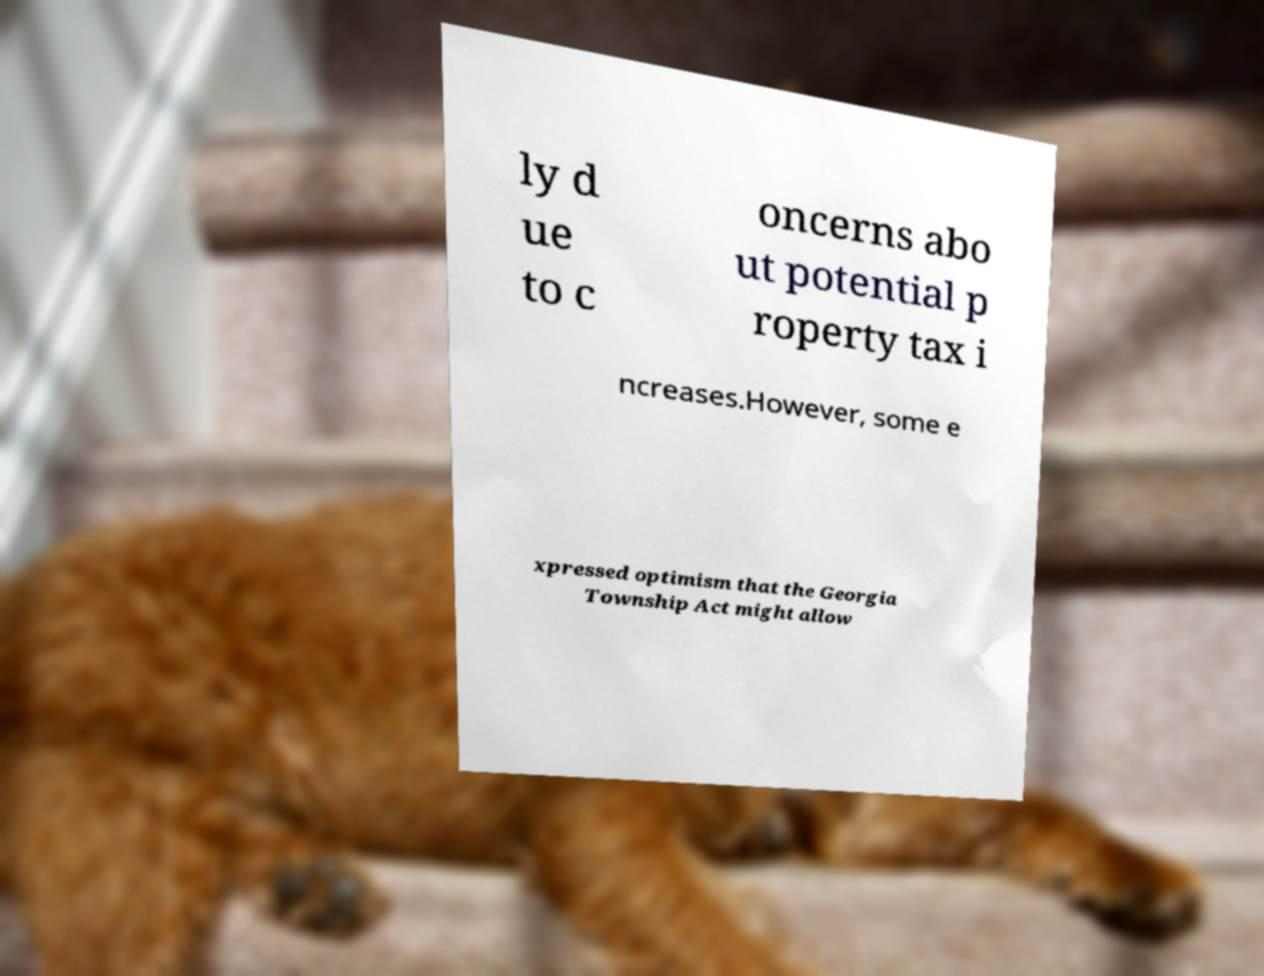For documentation purposes, I need the text within this image transcribed. Could you provide that? ly d ue to c oncerns abo ut potential p roperty tax i ncreases.However, some e xpressed optimism that the Georgia Township Act might allow 